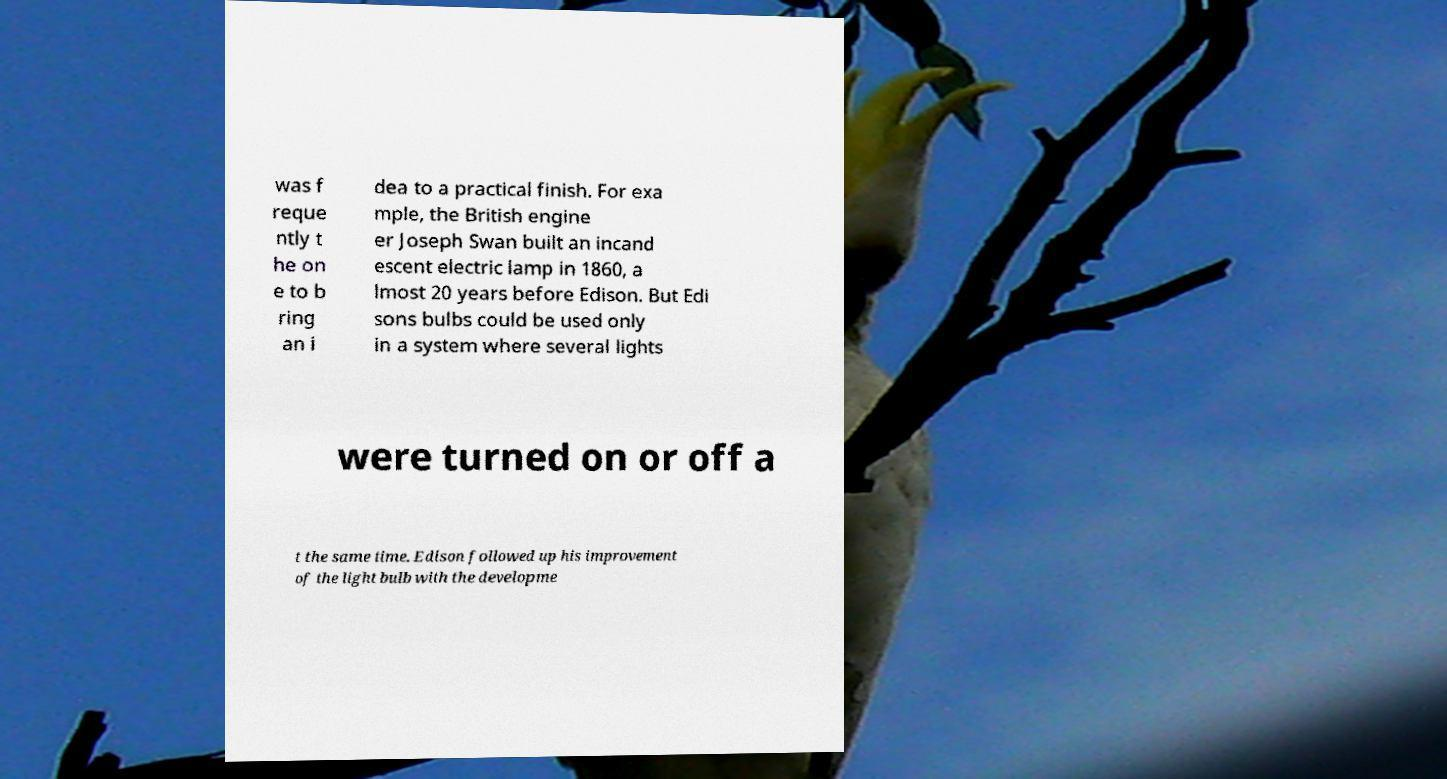For documentation purposes, I need the text within this image transcribed. Could you provide that? was f reque ntly t he on e to b ring an i dea to a practical finish. For exa mple, the British engine er Joseph Swan built an incand escent electric lamp in 1860, a lmost 20 years before Edison. But Edi sons bulbs could be used only in a system where several lights were turned on or off a t the same time. Edison followed up his improvement of the light bulb with the developme 